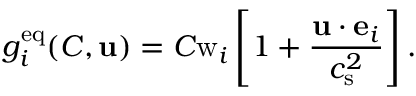Convert formula to latex. <formula><loc_0><loc_0><loc_500><loc_500>g _ { i } ^ { e q } ( C , u ) = C w _ { i } \left [ 1 + \frac { u \cdot e _ { i } } { c _ { s } ^ { 2 } } \right ] .</formula> 